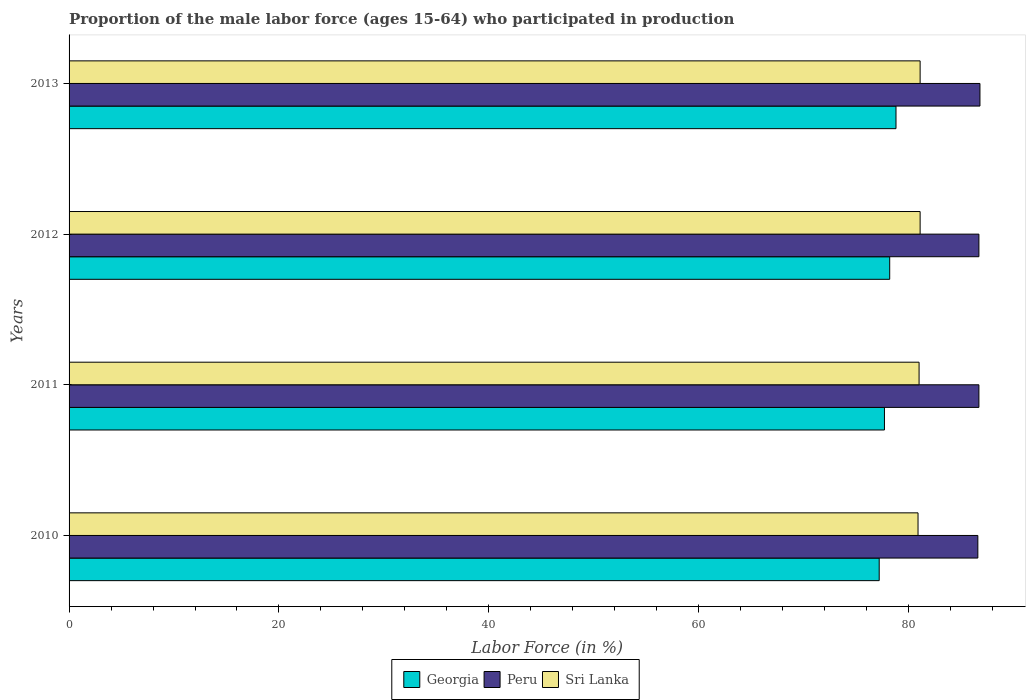How many different coloured bars are there?
Give a very brief answer. 3. Are the number of bars per tick equal to the number of legend labels?
Offer a terse response. Yes. Are the number of bars on each tick of the Y-axis equal?
Your response must be concise. Yes. What is the proportion of the male labor force who participated in production in Sri Lanka in 2013?
Offer a terse response. 81.1. Across all years, what is the maximum proportion of the male labor force who participated in production in Sri Lanka?
Ensure brevity in your answer.  81.1. Across all years, what is the minimum proportion of the male labor force who participated in production in Peru?
Ensure brevity in your answer.  86.6. In which year was the proportion of the male labor force who participated in production in Georgia maximum?
Your answer should be very brief. 2013. In which year was the proportion of the male labor force who participated in production in Peru minimum?
Keep it short and to the point. 2010. What is the total proportion of the male labor force who participated in production in Georgia in the graph?
Ensure brevity in your answer.  311.9. What is the difference between the proportion of the male labor force who participated in production in Georgia in 2010 and the proportion of the male labor force who participated in production in Sri Lanka in 2011?
Your response must be concise. -3.8. What is the average proportion of the male labor force who participated in production in Georgia per year?
Ensure brevity in your answer.  77.97. In the year 2013, what is the difference between the proportion of the male labor force who participated in production in Peru and proportion of the male labor force who participated in production in Georgia?
Offer a very short reply. 8. In how many years, is the proportion of the male labor force who participated in production in Peru greater than 4 %?
Keep it short and to the point. 4. What is the ratio of the proportion of the male labor force who participated in production in Sri Lanka in 2011 to that in 2012?
Keep it short and to the point. 1. Is the proportion of the male labor force who participated in production in Peru in 2011 less than that in 2013?
Give a very brief answer. Yes. Is the difference between the proportion of the male labor force who participated in production in Peru in 2010 and 2011 greater than the difference between the proportion of the male labor force who participated in production in Georgia in 2010 and 2011?
Offer a terse response. Yes. What is the difference between the highest and the second highest proportion of the male labor force who participated in production in Peru?
Offer a very short reply. 0.1. What is the difference between the highest and the lowest proportion of the male labor force who participated in production in Georgia?
Ensure brevity in your answer.  1.6. In how many years, is the proportion of the male labor force who participated in production in Sri Lanka greater than the average proportion of the male labor force who participated in production in Sri Lanka taken over all years?
Make the answer very short. 2. What does the 1st bar from the top in 2010 represents?
Keep it short and to the point. Sri Lanka. What does the 1st bar from the bottom in 2013 represents?
Make the answer very short. Georgia. Are all the bars in the graph horizontal?
Make the answer very short. Yes. What is the difference between two consecutive major ticks on the X-axis?
Your response must be concise. 20. Are the values on the major ticks of X-axis written in scientific E-notation?
Provide a succinct answer. No. Does the graph contain grids?
Your answer should be very brief. No. Where does the legend appear in the graph?
Your response must be concise. Bottom center. How many legend labels are there?
Your response must be concise. 3. How are the legend labels stacked?
Make the answer very short. Horizontal. What is the title of the graph?
Provide a short and direct response. Proportion of the male labor force (ages 15-64) who participated in production. Does "Slovak Republic" appear as one of the legend labels in the graph?
Offer a very short reply. No. What is the Labor Force (in %) of Georgia in 2010?
Offer a terse response. 77.2. What is the Labor Force (in %) of Peru in 2010?
Ensure brevity in your answer.  86.6. What is the Labor Force (in %) in Sri Lanka in 2010?
Give a very brief answer. 80.9. What is the Labor Force (in %) of Georgia in 2011?
Ensure brevity in your answer.  77.7. What is the Labor Force (in %) in Peru in 2011?
Give a very brief answer. 86.7. What is the Labor Force (in %) in Georgia in 2012?
Your answer should be compact. 78.2. What is the Labor Force (in %) of Peru in 2012?
Provide a succinct answer. 86.7. What is the Labor Force (in %) of Sri Lanka in 2012?
Provide a short and direct response. 81.1. What is the Labor Force (in %) of Georgia in 2013?
Your answer should be compact. 78.8. What is the Labor Force (in %) in Peru in 2013?
Your answer should be very brief. 86.8. What is the Labor Force (in %) of Sri Lanka in 2013?
Offer a terse response. 81.1. Across all years, what is the maximum Labor Force (in %) of Georgia?
Your response must be concise. 78.8. Across all years, what is the maximum Labor Force (in %) of Peru?
Provide a succinct answer. 86.8. Across all years, what is the maximum Labor Force (in %) of Sri Lanka?
Give a very brief answer. 81.1. Across all years, what is the minimum Labor Force (in %) of Georgia?
Provide a succinct answer. 77.2. Across all years, what is the minimum Labor Force (in %) of Peru?
Give a very brief answer. 86.6. Across all years, what is the minimum Labor Force (in %) of Sri Lanka?
Your response must be concise. 80.9. What is the total Labor Force (in %) of Georgia in the graph?
Provide a succinct answer. 311.9. What is the total Labor Force (in %) in Peru in the graph?
Make the answer very short. 346.8. What is the total Labor Force (in %) in Sri Lanka in the graph?
Offer a terse response. 324.1. What is the difference between the Labor Force (in %) of Georgia in 2010 and that in 2011?
Your answer should be compact. -0.5. What is the difference between the Labor Force (in %) of Peru in 2010 and that in 2011?
Ensure brevity in your answer.  -0.1. What is the difference between the Labor Force (in %) in Georgia in 2010 and that in 2012?
Give a very brief answer. -1. What is the difference between the Labor Force (in %) in Georgia in 2010 and that in 2013?
Provide a succinct answer. -1.6. What is the difference between the Labor Force (in %) in Peru in 2010 and that in 2013?
Your response must be concise. -0.2. What is the difference between the Labor Force (in %) of Georgia in 2011 and that in 2013?
Your answer should be very brief. -1.1. What is the difference between the Labor Force (in %) of Peru in 2011 and that in 2013?
Provide a short and direct response. -0.1. What is the difference between the Labor Force (in %) in Georgia in 2010 and the Labor Force (in %) in Peru in 2011?
Make the answer very short. -9.5. What is the difference between the Labor Force (in %) in Georgia in 2010 and the Labor Force (in %) in Peru in 2012?
Offer a very short reply. -9.5. What is the difference between the Labor Force (in %) in Peru in 2010 and the Labor Force (in %) in Sri Lanka in 2012?
Ensure brevity in your answer.  5.5. What is the difference between the Labor Force (in %) in Georgia in 2010 and the Labor Force (in %) in Peru in 2013?
Give a very brief answer. -9.6. What is the difference between the Labor Force (in %) in Georgia in 2010 and the Labor Force (in %) in Sri Lanka in 2013?
Offer a terse response. -3.9. What is the difference between the Labor Force (in %) in Peru in 2010 and the Labor Force (in %) in Sri Lanka in 2013?
Ensure brevity in your answer.  5.5. What is the difference between the Labor Force (in %) of Georgia in 2011 and the Labor Force (in %) of Sri Lanka in 2012?
Keep it short and to the point. -3.4. What is the difference between the Labor Force (in %) in Peru in 2011 and the Labor Force (in %) in Sri Lanka in 2012?
Provide a succinct answer. 5.6. What is the difference between the Labor Force (in %) in Georgia in 2011 and the Labor Force (in %) in Sri Lanka in 2013?
Your answer should be very brief. -3.4. What is the difference between the Labor Force (in %) in Georgia in 2012 and the Labor Force (in %) in Peru in 2013?
Ensure brevity in your answer.  -8.6. What is the difference between the Labor Force (in %) of Georgia in 2012 and the Labor Force (in %) of Sri Lanka in 2013?
Offer a very short reply. -2.9. What is the average Labor Force (in %) in Georgia per year?
Your answer should be compact. 77.97. What is the average Labor Force (in %) of Peru per year?
Provide a short and direct response. 86.7. What is the average Labor Force (in %) in Sri Lanka per year?
Offer a very short reply. 81.03. In the year 2010, what is the difference between the Labor Force (in %) of Georgia and Labor Force (in %) of Peru?
Your response must be concise. -9.4. In the year 2010, what is the difference between the Labor Force (in %) of Georgia and Labor Force (in %) of Sri Lanka?
Your answer should be very brief. -3.7. In the year 2010, what is the difference between the Labor Force (in %) of Peru and Labor Force (in %) of Sri Lanka?
Give a very brief answer. 5.7. In the year 2011, what is the difference between the Labor Force (in %) in Georgia and Labor Force (in %) in Peru?
Provide a succinct answer. -9. In the year 2011, what is the difference between the Labor Force (in %) in Peru and Labor Force (in %) in Sri Lanka?
Provide a short and direct response. 5.7. In the year 2012, what is the difference between the Labor Force (in %) of Georgia and Labor Force (in %) of Sri Lanka?
Your answer should be very brief. -2.9. What is the ratio of the Labor Force (in %) of Georgia in 2010 to that in 2011?
Your response must be concise. 0.99. What is the ratio of the Labor Force (in %) in Georgia in 2010 to that in 2012?
Your answer should be very brief. 0.99. What is the ratio of the Labor Force (in %) in Georgia in 2010 to that in 2013?
Offer a terse response. 0.98. What is the ratio of the Labor Force (in %) of Peru in 2011 to that in 2013?
Your response must be concise. 1. What is the ratio of the Labor Force (in %) in Peru in 2012 to that in 2013?
Ensure brevity in your answer.  1. What is the difference between the highest and the second highest Labor Force (in %) of Sri Lanka?
Your response must be concise. 0. What is the difference between the highest and the lowest Labor Force (in %) of Georgia?
Your response must be concise. 1.6. What is the difference between the highest and the lowest Labor Force (in %) in Peru?
Your response must be concise. 0.2. What is the difference between the highest and the lowest Labor Force (in %) in Sri Lanka?
Keep it short and to the point. 0.2. 